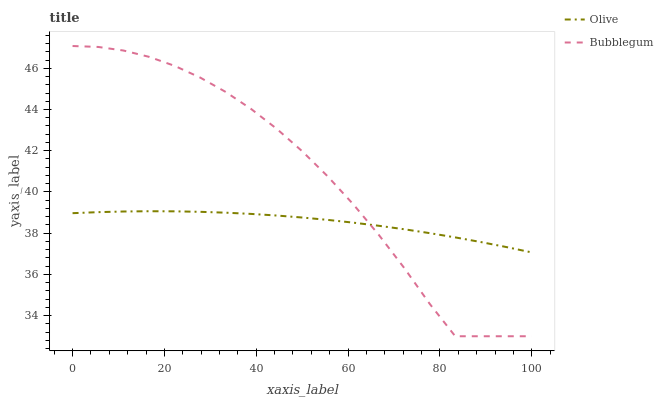Does Olive have the minimum area under the curve?
Answer yes or no. Yes. Does Bubblegum have the maximum area under the curve?
Answer yes or no. Yes. Does Bubblegum have the minimum area under the curve?
Answer yes or no. No. Is Olive the smoothest?
Answer yes or no. Yes. Is Bubblegum the roughest?
Answer yes or no. Yes. Is Bubblegum the smoothest?
Answer yes or no. No. Does Bubblegum have the lowest value?
Answer yes or no. Yes. Does Bubblegum have the highest value?
Answer yes or no. Yes. Does Olive intersect Bubblegum?
Answer yes or no. Yes. Is Olive less than Bubblegum?
Answer yes or no. No. Is Olive greater than Bubblegum?
Answer yes or no. No. 